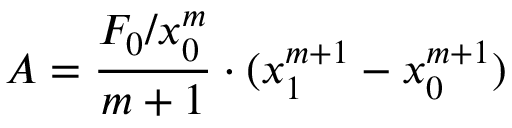Convert formula to latex. <formula><loc_0><loc_0><loc_500><loc_500>A = { \frac { F _ { 0 } / x _ { 0 } ^ { m } } { m + 1 } } \cdot ( x _ { 1 } ^ { m + 1 } - x _ { 0 } ^ { m + 1 } )</formula> 